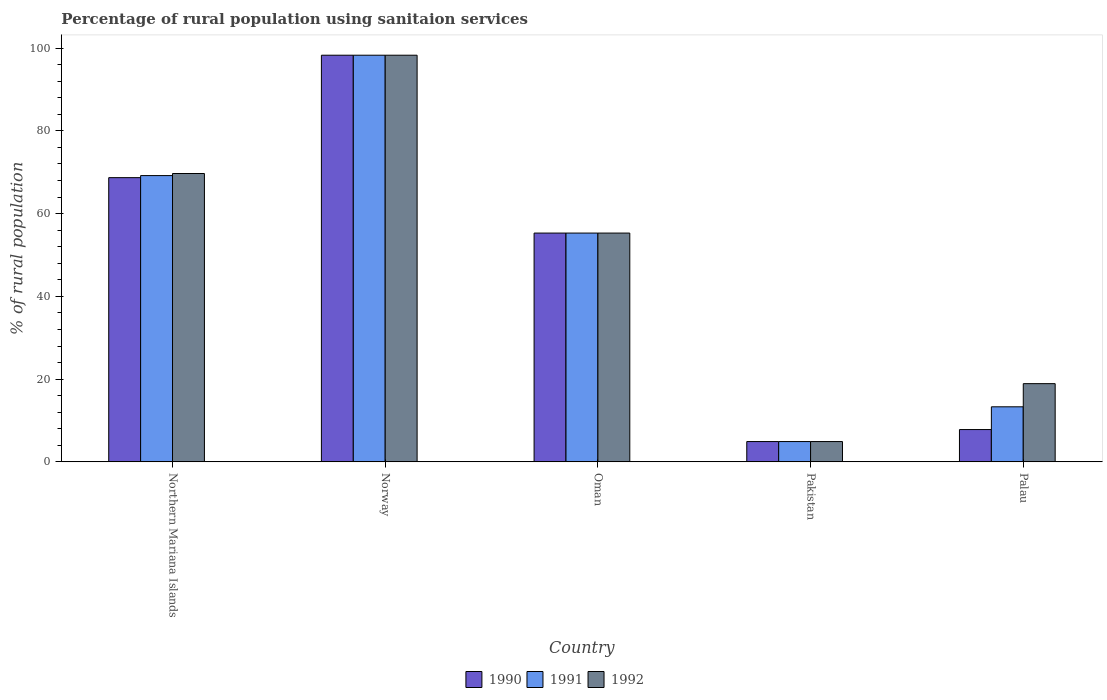How many groups of bars are there?
Offer a terse response. 5. Are the number of bars per tick equal to the number of legend labels?
Offer a terse response. Yes. Are the number of bars on each tick of the X-axis equal?
Keep it short and to the point. Yes. How many bars are there on the 5th tick from the left?
Make the answer very short. 3. How many bars are there on the 5th tick from the right?
Offer a very short reply. 3. What is the label of the 5th group of bars from the left?
Offer a terse response. Palau. In how many cases, is the number of bars for a given country not equal to the number of legend labels?
Offer a very short reply. 0. What is the percentage of rural population using sanitaion services in 1990 in Norway?
Provide a succinct answer. 98.3. Across all countries, what is the maximum percentage of rural population using sanitaion services in 1992?
Provide a short and direct response. 98.3. Across all countries, what is the minimum percentage of rural population using sanitaion services in 1990?
Your answer should be very brief. 4.9. In which country was the percentage of rural population using sanitaion services in 1991 maximum?
Ensure brevity in your answer.  Norway. In which country was the percentage of rural population using sanitaion services in 1990 minimum?
Your answer should be compact. Pakistan. What is the total percentage of rural population using sanitaion services in 1992 in the graph?
Offer a very short reply. 247.1. What is the difference between the percentage of rural population using sanitaion services in 1991 in Northern Mariana Islands and that in Oman?
Your response must be concise. 13.9. What is the difference between the percentage of rural population using sanitaion services in 1990 in Pakistan and the percentage of rural population using sanitaion services in 1992 in Palau?
Your answer should be compact. -14. What is the average percentage of rural population using sanitaion services in 1991 per country?
Your response must be concise. 48.2. What is the difference between the percentage of rural population using sanitaion services of/in 1990 and percentage of rural population using sanitaion services of/in 1991 in Palau?
Keep it short and to the point. -5.5. In how many countries, is the percentage of rural population using sanitaion services in 1992 greater than 32 %?
Your answer should be very brief. 3. What is the ratio of the percentage of rural population using sanitaion services in 1992 in Norway to that in Oman?
Your answer should be compact. 1.78. Is the percentage of rural population using sanitaion services in 1990 in Oman less than that in Pakistan?
Ensure brevity in your answer.  No. Is the difference between the percentage of rural population using sanitaion services in 1990 in Northern Mariana Islands and Oman greater than the difference between the percentage of rural population using sanitaion services in 1991 in Northern Mariana Islands and Oman?
Offer a very short reply. No. What is the difference between the highest and the second highest percentage of rural population using sanitaion services in 1990?
Your answer should be very brief. 29.6. What is the difference between the highest and the lowest percentage of rural population using sanitaion services in 1990?
Ensure brevity in your answer.  93.4. Is the sum of the percentage of rural population using sanitaion services in 1990 in Norway and Pakistan greater than the maximum percentage of rural population using sanitaion services in 1991 across all countries?
Offer a very short reply. Yes. What does the 2nd bar from the right in Norway represents?
Make the answer very short. 1991. Is it the case that in every country, the sum of the percentage of rural population using sanitaion services in 1991 and percentage of rural population using sanitaion services in 1992 is greater than the percentage of rural population using sanitaion services in 1990?
Provide a succinct answer. Yes. How many bars are there?
Keep it short and to the point. 15. Are all the bars in the graph horizontal?
Make the answer very short. No. How many countries are there in the graph?
Your answer should be very brief. 5. Are the values on the major ticks of Y-axis written in scientific E-notation?
Provide a short and direct response. No. How many legend labels are there?
Your response must be concise. 3. What is the title of the graph?
Keep it short and to the point. Percentage of rural population using sanitaion services. What is the label or title of the X-axis?
Ensure brevity in your answer.  Country. What is the label or title of the Y-axis?
Your answer should be very brief. % of rural population. What is the % of rural population of 1990 in Northern Mariana Islands?
Provide a short and direct response. 68.7. What is the % of rural population in 1991 in Northern Mariana Islands?
Your response must be concise. 69.2. What is the % of rural population of 1992 in Northern Mariana Islands?
Your answer should be compact. 69.7. What is the % of rural population of 1990 in Norway?
Offer a very short reply. 98.3. What is the % of rural population in 1991 in Norway?
Ensure brevity in your answer.  98.3. What is the % of rural population of 1992 in Norway?
Offer a terse response. 98.3. What is the % of rural population in 1990 in Oman?
Your response must be concise. 55.3. What is the % of rural population of 1991 in Oman?
Keep it short and to the point. 55.3. What is the % of rural population in 1992 in Oman?
Make the answer very short. 55.3. What is the % of rural population in 1990 in Pakistan?
Make the answer very short. 4.9. What is the % of rural population in 1991 in Pakistan?
Provide a short and direct response. 4.9. What is the % of rural population in 1992 in Pakistan?
Your response must be concise. 4.9. Across all countries, what is the maximum % of rural population in 1990?
Your answer should be very brief. 98.3. Across all countries, what is the maximum % of rural population in 1991?
Offer a terse response. 98.3. Across all countries, what is the maximum % of rural population in 1992?
Provide a succinct answer. 98.3. Across all countries, what is the minimum % of rural population in 1990?
Your answer should be very brief. 4.9. Across all countries, what is the minimum % of rural population in 1991?
Provide a short and direct response. 4.9. What is the total % of rural population of 1990 in the graph?
Provide a succinct answer. 235. What is the total % of rural population in 1991 in the graph?
Ensure brevity in your answer.  241. What is the total % of rural population of 1992 in the graph?
Make the answer very short. 247.1. What is the difference between the % of rural population of 1990 in Northern Mariana Islands and that in Norway?
Offer a very short reply. -29.6. What is the difference between the % of rural population in 1991 in Northern Mariana Islands and that in Norway?
Your response must be concise. -29.1. What is the difference between the % of rural population in 1992 in Northern Mariana Islands and that in Norway?
Your answer should be compact. -28.6. What is the difference between the % of rural population of 1992 in Northern Mariana Islands and that in Oman?
Provide a succinct answer. 14.4. What is the difference between the % of rural population in 1990 in Northern Mariana Islands and that in Pakistan?
Offer a terse response. 63.8. What is the difference between the % of rural population of 1991 in Northern Mariana Islands and that in Pakistan?
Offer a very short reply. 64.3. What is the difference between the % of rural population in 1992 in Northern Mariana Islands and that in Pakistan?
Your answer should be compact. 64.8. What is the difference between the % of rural population of 1990 in Northern Mariana Islands and that in Palau?
Offer a terse response. 60.9. What is the difference between the % of rural population in 1991 in Northern Mariana Islands and that in Palau?
Give a very brief answer. 55.9. What is the difference between the % of rural population of 1992 in Northern Mariana Islands and that in Palau?
Give a very brief answer. 50.8. What is the difference between the % of rural population in 1991 in Norway and that in Oman?
Your answer should be very brief. 43. What is the difference between the % of rural population of 1992 in Norway and that in Oman?
Offer a very short reply. 43. What is the difference between the % of rural population of 1990 in Norway and that in Pakistan?
Provide a short and direct response. 93.4. What is the difference between the % of rural population of 1991 in Norway and that in Pakistan?
Make the answer very short. 93.4. What is the difference between the % of rural population of 1992 in Norway and that in Pakistan?
Your answer should be very brief. 93.4. What is the difference between the % of rural population in 1990 in Norway and that in Palau?
Your answer should be compact. 90.5. What is the difference between the % of rural population in 1991 in Norway and that in Palau?
Offer a very short reply. 85. What is the difference between the % of rural population of 1992 in Norway and that in Palau?
Offer a terse response. 79.4. What is the difference between the % of rural population in 1990 in Oman and that in Pakistan?
Provide a short and direct response. 50.4. What is the difference between the % of rural population of 1991 in Oman and that in Pakistan?
Offer a very short reply. 50.4. What is the difference between the % of rural population of 1992 in Oman and that in Pakistan?
Offer a terse response. 50.4. What is the difference between the % of rural population in 1990 in Oman and that in Palau?
Offer a very short reply. 47.5. What is the difference between the % of rural population in 1992 in Oman and that in Palau?
Keep it short and to the point. 36.4. What is the difference between the % of rural population in 1992 in Pakistan and that in Palau?
Your answer should be compact. -14. What is the difference between the % of rural population of 1990 in Northern Mariana Islands and the % of rural population of 1991 in Norway?
Keep it short and to the point. -29.6. What is the difference between the % of rural population of 1990 in Northern Mariana Islands and the % of rural population of 1992 in Norway?
Keep it short and to the point. -29.6. What is the difference between the % of rural population in 1991 in Northern Mariana Islands and the % of rural population in 1992 in Norway?
Keep it short and to the point. -29.1. What is the difference between the % of rural population of 1990 in Northern Mariana Islands and the % of rural population of 1991 in Oman?
Offer a terse response. 13.4. What is the difference between the % of rural population of 1991 in Northern Mariana Islands and the % of rural population of 1992 in Oman?
Keep it short and to the point. 13.9. What is the difference between the % of rural population of 1990 in Northern Mariana Islands and the % of rural population of 1991 in Pakistan?
Provide a succinct answer. 63.8. What is the difference between the % of rural population in 1990 in Northern Mariana Islands and the % of rural population in 1992 in Pakistan?
Give a very brief answer. 63.8. What is the difference between the % of rural population of 1991 in Northern Mariana Islands and the % of rural population of 1992 in Pakistan?
Provide a succinct answer. 64.3. What is the difference between the % of rural population in 1990 in Northern Mariana Islands and the % of rural population in 1991 in Palau?
Provide a short and direct response. 55.4. What is the difference between the % of rural population in 1990 in Northern Mariana Islands and the % of rural population in 1992 in Palau?
Keep it short and to the point. 49.8. What is the difference between the % of rural population in 1991 in Northern Mariana Islands and the % of rural population in 1992 in Palau?
Ensure brevity in your answer.  50.3. What is the difference between the % of rural population in 1990 in Norway and the % of rural population in 1991 in Oman?
Offer a very short reply. 43. What is the difference between the % of rural population in 1990 in Norway and the % of rural population in 1992 in Oman?
Your answer should be compact. 43. What is the difference between the % of rural population in 1990 in Norway and the % of rural population in 1991 in Pakistan?
Provide a succinct answer. 93.4. What is the difference between the % of rural population in 1990 in Norway and the % of rural population in 1992 in Pakistan?
Provide a succinct answer. 93.4. What is the difference between the % of rural population in 1991 in Norway and the % of rural population in 1992 in Pakistan?
Keep it short and to the point. 93.4. What is the difference between the % of rural population in 1990 in Norway and the % of rural population in 1991 in Palau?
Provide a short and direct response. 85. What is the difference between the % of rural population in 1990 in Norway and the % of rural population in 1992 in Palau?
Your answer should be very brief. 79.4. What is the difference between the % of rural population of 1991 in Norway and the % of rural population of 1992 in Palau?
Your response must be concise. 79.4. What is the difference between the % of rural population of 1990 in Oman and the % of rural population of 1991 in Pakistan?
Provide a short and direct response. 50.4. What is the difference between the % of rural population of 1990 in Oman and the % of rural population of 1992 in Pakistan?
Provide a short and direct response. 50.4. What is the difference between the % of rural population of 1991 in Oman and the % of rural population of 1992 in Pakistan?
Your response must be concise. 50.4. What is the difference between the % of rural population of 1990 in Oman and the % of rural population of 1992 in Palau?
Ensure brevity in your answer.  36.4. What is the difference between the % of rural population in 1991 in Oman and the % of rural population in 1992 in Palau?
Provide a short and direct response. 36.4. What is the average % of rural population in 1991 per country?
Offer a terse response. 48.2. What is the average % of rural population in 1992 per country?
Your answer should be very brief. 49.42. What is the difference between the % of rural population of 1990 and % of rural population of 1991 in Northern Mariana Islands?
Keep it short and to the point. -0.5. What is the difference between the % of rural population in 1990 and % of rural population in 1992 in Northern Mariana Islands?
Ensure brevity in your answer.  -1. What is the difference between the % of rural population of 1991 and % of rural population of 1992 in Northern Mariana Islands?
Offer a terse response. -0.5. What is the difference between the % of rural population of 1990 and % of rural population of 1992 in Oman?
Your answer should be very brief. 0. What is the difference between the % of rural population in 1991 and % of rural population in 1992 in Oman?
Make the answer very short. 0. What is the difference between the % of rural population of 1990 and % of rural population of 1992 in Pakistan?
Keep it short and to the point. 0. What is the difference between the % of rural population in 1990 and % of rural population in 1992 in Palau?
Your answer should be very brief. -11.1. What is the difference between the % of rural population in 1991 and % of rural population in 1992 in Palau?
Offer a very short reply. -5.6. What is the ratio of the % of rural population in 1990 in Northern Mariana Islands to that in Norway?
Keep it short and to the point. 0.7. What is the ratio of the % of rural population in 1991 in Northern Mariana Islands to that in Norway?
Offer a very short reply. 0.7. What is the ratio of the % of rural population of 1992 in Northern Mariana Islands to that in Norway?
Your answer should be compact. 0.71. What is the ratio of the % of rural population in 1990 in Northern Mariana Islands to that in Oman?
Ensure brevity in your answer.  1.24. What is the ratio of the % of rural population in 1991 in Northern Mariana Islands to that in Oman?
Offer a very short reply. 1.25. What is the ratio of the % of rural population in 1992 in Northern Mariana Islands to that in Oman?
Your answer should be compact. 1.26. What is the ratio of the % of rural population of 1990 in Northern Mariana Islands to that in Pakistan?
Your answer should be very brief. 14.02. What is the ratio of the % of rural population in 1991 in Northern Mariana Islands to that in Pakistan?
Offer a terse response. 14.12. What is the ratio of the % of rural population of 1992 in Northern Mariana Islands to that in Pakistan?
Ensure brevity in your answer.  14.22. What is the ratio of the % of rural population of 1990 in Northern Mariana Islands to that in Palau?
Your answer should be very brief. 8.81. What is the ratio of the % of rural population of 1991 in Northern Mariana Islands to that in Palau?
Offer a terse response. 5.2. What is the ratio of the % of rural population of 1992 in Northern Mariana Islands to that in Palau?
Your answer should be compact. 3.69. What is the ratio of the % of rural population of 1990 in Norway to that in Oman?
Provide a short and direct response. 1.78. What is the ratio of the % of rural population in 1991 in Norway to that in Oman?
Keep it short and to the point. 1.78. What is the ratio of the % of rural population in 1992 in Norway to that in Oman?
Make the answer very short. 1.78. What is the ratio of the % of rural population of 1990 in Norway to that in Pakistan?
Ensure brevity in your answer.  20.06. What is the ratio of the % of rural population in 1991 in Norway to that in Pakistan?
Your answer should be compact. 20.06. What is the ratio of the % of rural population of 1992 in Norway to that in Pakistan?
Keep it short and to the point. 20.06. What is the ratio of the % of rural population of 1990 in Norway to that in Palau?
Your answer should be very brief. 12.6. What is the ratio of the % of rural population in 1991 in Norway to that in Palau?
Provide a succinct answer. 7.39. What is the ratio of the % of rural population in 1992 in Norway to that in Palau?
Provide a short and direct response. 5.2. What is the ratio of the % of rural population of 1990 in Oman to that in Pakistan?
Offer a very short reply. 11.29. What is the ratio of the % of rural population in 1991 in Oman to that in Pakistan?
Offer a very short reply. 11.29. What is the ratio of the % of rural population in 1992 in Oman to that in Pakistan?
Offer a terse response. 11.29. What is the ratio of the % of rural population in 1990 in Oman to that in Palau?
Offer a terse response. 7.09. What is the ratio of the % of rural population of 1991 in Oman to that in Palau?
Make the answer very short. 4.16. What is the ratio of the % of rural population in 1992 in Oman to that in Palau?
Your response must be concise. 2.93. What is the ratio of the % of rural population of 1990 in Pakistan to that in Palau?
Provide a succinct answer. 0.63. What is the ratio of the % of rural population of 1991 in Pakistan to that in Palau?
Ensure brevity in your answer.  0.37. What is the ratio of the % of rural population in 1992 in Pakistan to that in Palau?
Make the answer very short. 0.26. What is the difference between the highest and the second highest % of rural population of 1990?
Your answer should be very brief. 29.6. What is the difference between the highest and the second highest % of rural population in 1991?
Your answer should be very brief. 29.1. What is the difference between the highest and the second highest % of rural population in 1992?
Your answer should be very brief. 28.6. What is the difference between the highest and the lowest % of rural population in 1990?
Your response must be concise. 93.4. What is the difference between the highest and the lowest % of rural population of 1991?
Offer a terse response. 93.4. What is the difference between the highest and the lowest % of rural population of 1992?
Offer a terse response. 93.4. 